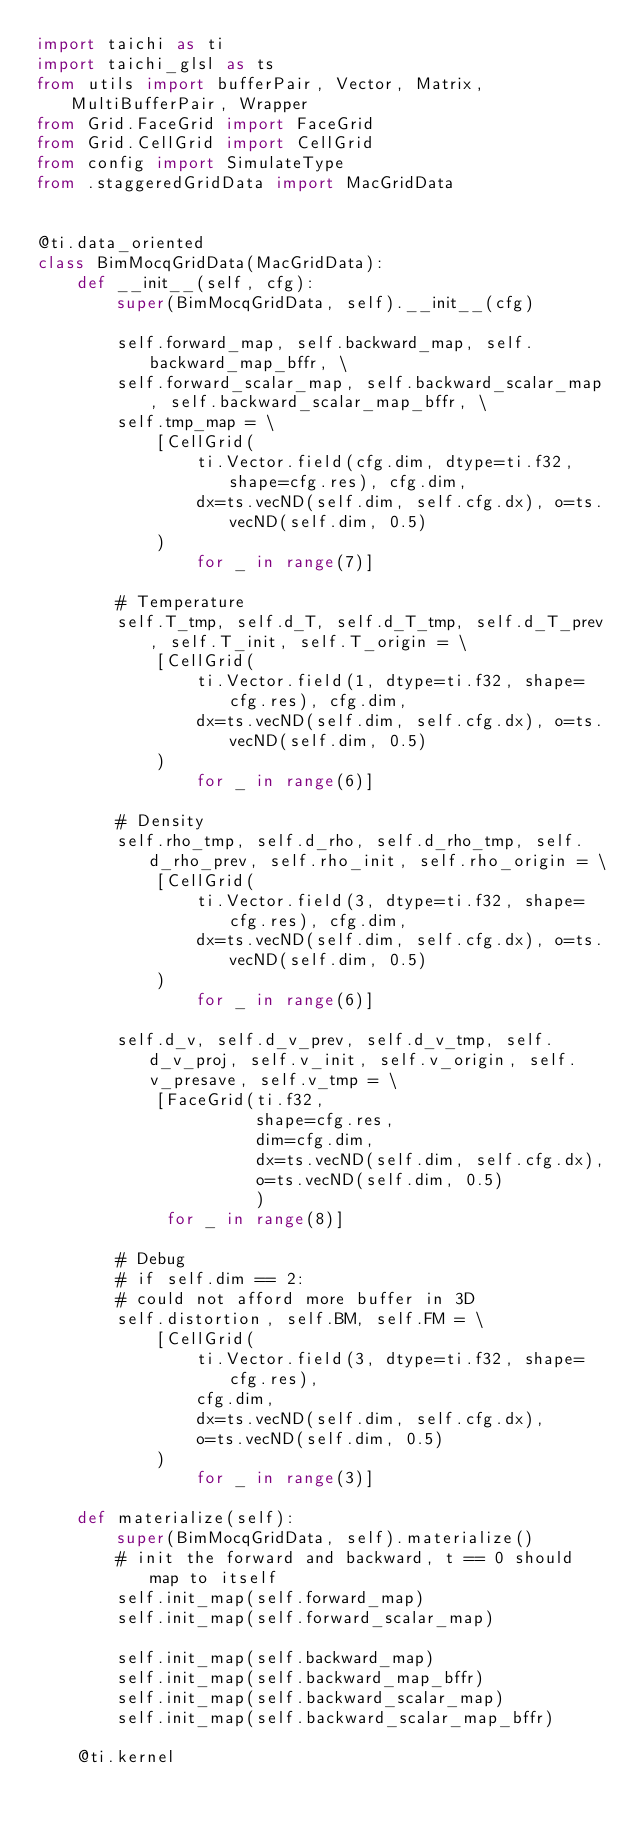<code> <loc_0><loc_0><loc_500><loc_500><_Python_>import taichi as ti
import taichi_glsl as ts
from utils import bufferPair, Vector, Matrix, MultiBufferPair, Wrapper
from Grid.FaceGrid import FaceGrid
from Grid.CellGrid import CellGrid
from config import SimulateType
from .staggeredGridData import MacGridData


@ti.data_oriented
class BimMocqGridData(MacGridData):
    def __init__(self, cfg):
        super(BimMocqGridData, self).__init__(cfg)

        self.forward_map, self.backward_map, self.backward_map_bffr, \
        self.forward_scalar_map, self.backward_scalar_map, self.backward_scalar_map_bffr, \
        self.tmp_map = \
            [CellGrid(
                ti.Vector.field(cfg.dim, dtype=ti.f32, shape=cfg.res), cfg.dim,
                dx=ts.vecND(self.dim, self.cfg.dx), o=ts.vecND(self.dim, 0.5)
            )
                for _ in range(7)]

        # Temperature
        self.T_tmp, self.d_T, self.d_T_tmp, self.d_T_prev, self.T_init, self.T_origin = \
            [CellGrid(
                ti.Vector.field(1, dtype=ti.f32, shape=cfg.res), cfg.dim,
                dx=ts.vecND(self.dim, self.cfg.dx), o=ts.vecND(self.dim, 0.5)
            )
                for _ in range(6)]

        # Density
        self.rho_tmp, self.d_rho, self.d_rho_tmp, self.d_rho_prev, self.rho_init, self.rho_origin = \
            [CellGrid(
                ti.Vector.field(3, dtype=ti.f32, shape=cfg.res), cfg.dim,
                dx=ts.vecND(self.dim, self.cfg.dx), o=ts.vecND(self.dim, 0.5)
            )
                for _ in range(6)]

        self.d_v, self.d_v_prev, self.d_v_tmp, self.d_v_proj, self.v_init, self.v_origin, self.v_presave, self.v_tmp = \
            [FaceGrid(ti.f32,
                      shape=cfg.res,
                      dim=cfg.dim,
                      dx=ts.vecND(self.dim, self.cfg.dx),
                      o=ts.vecND(self.dim, 0.5)
                      )
             for _ in range(8)]

        # Debug
        # if self.dim == 2:
        # could not afford more buffer in 3D
        self.distortion, self.BM, self.FM = \
            [CellGrid(
                ti.Vector.field(3, dtype=ti.f32, shape=cfg.res),
                cfg.dim,
                dx=ts.vecND(self.dim, self.cfg.dx),
                o=ts.vecND(self.dim, 0.5)
            )
                for _ in range(3)]

    def materialize(self):
        super(BimMocqGridData, self).materialize()
        # init the forward and backward, t == 0 should map to itself
        self.init_map(self.forward_map)
        self.init_map(self.forward_scalar_map)

        self.init_map(self.backward_map)
        self.init_map(self.backward_map_bffr)
        self.init_map(self.backward_scalar_map)
        self.init_map(self.backward_scalar_map_bffr)

    @ti.kernel</code> 